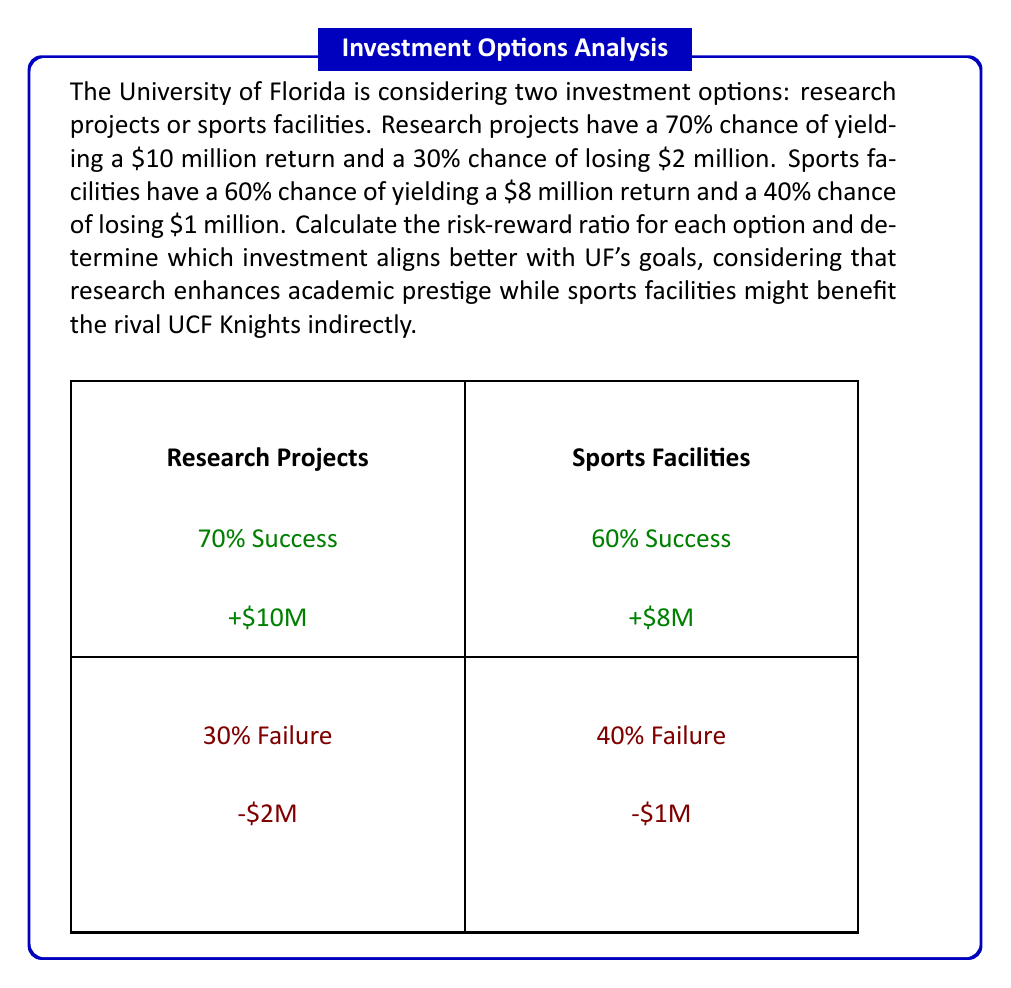Could you help me with this problem? Let's calculate the risk-reward ratio for each option:

1. Research Projects:
   Expected Return: $E_R = 0.7 \times 10 + 0.3 \times (-2) = 7 - 0.6 = 6.4$ million
   Standard Deviation: $\sigma_R = \sqrt{0.7 \times (10-6.4)^2 + 0.3 \times (-2-6.4)^2} \approx 5.37$ million
   Risk-Reward Ratio: $RRR_R = \frac{\sigma_R}{E_R} = \frac{5.37}{6.4} \approx 0.839$

2. Sports Facilities:
   Expected Return: $E_S = 0.6 \times 8 + 0.4 \times (-1) = 4.8 - 0.4 = 4.4$ million
   Standard Deviation: $\sigma_S = \sqrt{0.6 \times (8-4.4)^2 + 0.4 \times (-1-4.4)^2} \approx 4.13$ million
   Risk-Reward Ratio: $RRR_S = \frac{\sigma_S}{E_S} = \frac{4.13}{4.4} \approx 0.939$

A lower risk-reward ratio indicates a better investment option. Research projects have a lower ratio (0.839 < 0.939), suggesting they are a better investment.

Considering UF's goals:
1. Research projects enhance academic prestige, aligning with UF's primary mission.
2. Sports facilities might indirectly benefit rival UCF Knights, which goes against the given persona.

Therefore, investing in research projects is the better option for UF, considering both the quantitative analysis and the qualitative factors.
Answer: Invest in research projects (RRR: 0.839 < 0.939) 